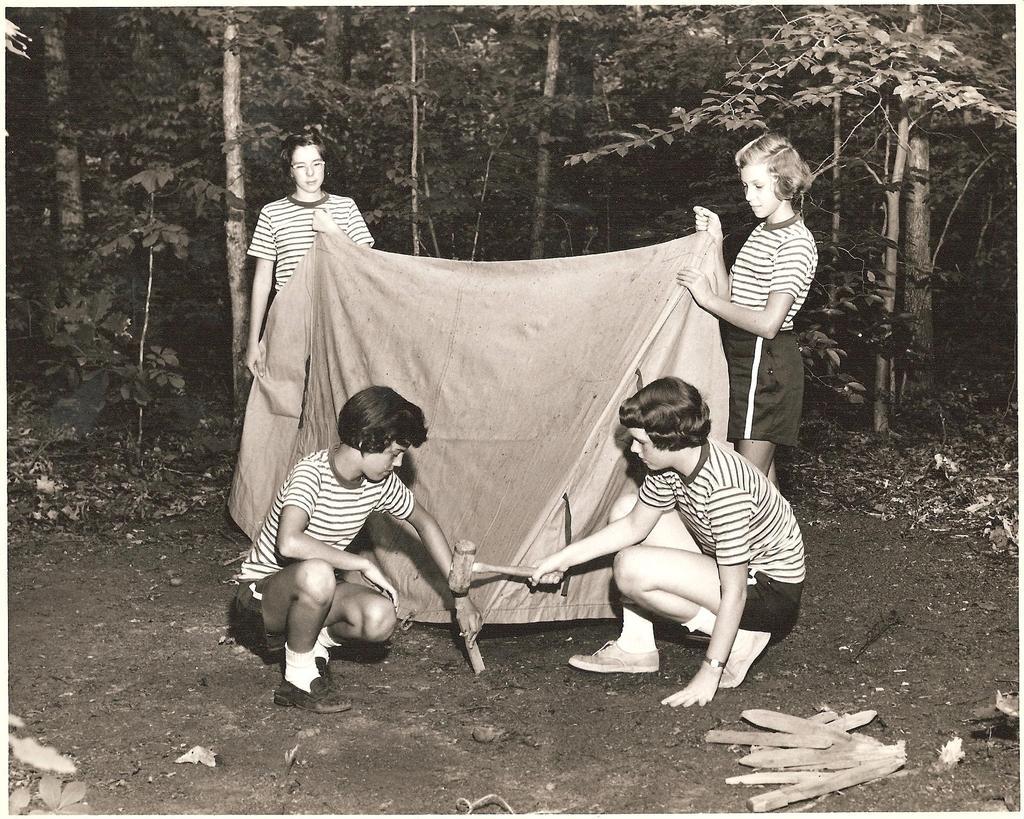Can you describe this image briefly? In this image in front there are two people holding the hammer and some object. Behind them there are two people holding the cloth. In the background of the image there are trees. 